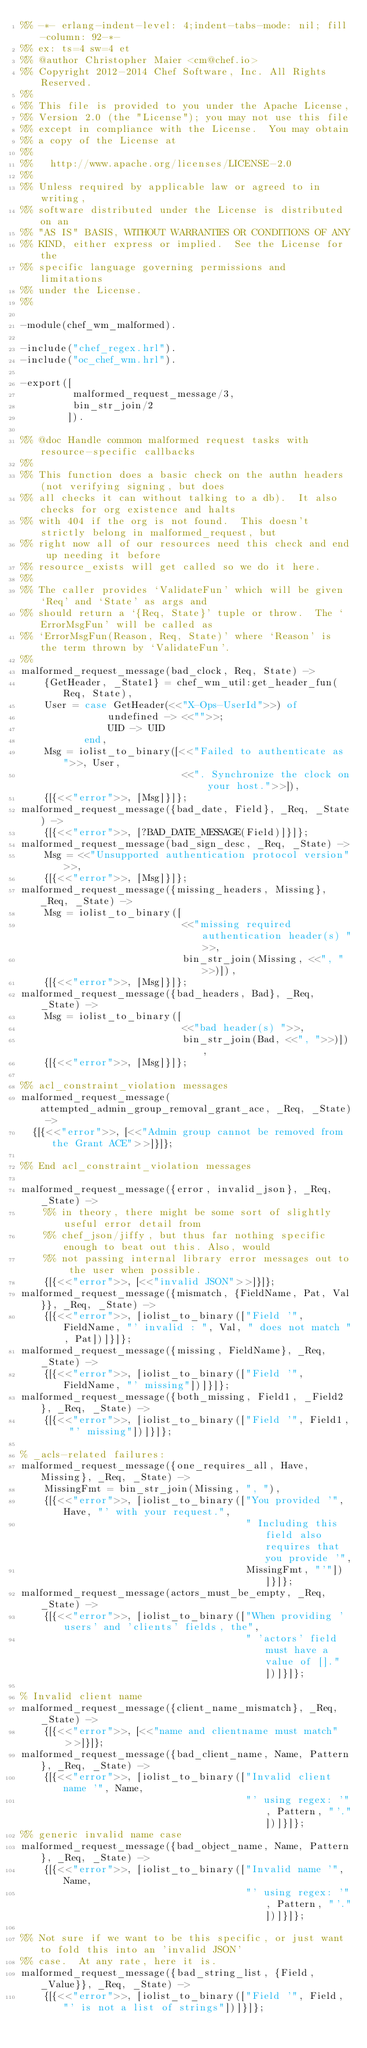Convert code to text. <code><loc_0><loc_0><loc_500><loc_500><_Erlang_>%% -*- erlang-indent-level: 4;indent-tabs-mode: nil; fill-column: 92-*-
%% ex: ts=4 sw=4 et
%% @author Christopher Maier <cm@chef.io>
%% Copyright 2012-2014 Chef Software, Inc. All Rights Reserved.
%%
%% This file is provided to you under the Apache License,
%% Version 2.0 (the "License"); you may not use this file
%% except in compliance with the License.  You may obtain
%% a copy of the License at
%%
%%   http://www.apache.org/licenses/LICENSE-2.0
%%
%% Unless required by applicable law or agreed to in writing,
%% software distributed under the License is distributed on an
%% "AS IS" BASIS, WITHOUT WARRANTIES OR CONDITIONS OF ANY
%% KIND, either express or implied.  See the License for the
%% specific language governing permissions and limitations
%% under the License.
%%

-module(chef_wm_malformed).

-include("chef_regex.hrl").
-include("oc_chef_wm.hrl").

-export([
         malformed_request_message/3,
         bin_str_join/2
        ]).

%% @doc Handle common malformed request tasks with resource-specific callbacks
%%
%% This function does a basic check on the authn headers (not verifying signing, but does
%% all checks it can without talking to a db).  It also checks for org existence and halts
%% with 404 if the org is not found.  This doesn't strictly belong in malformed_request, but
%% right now all of our resources need this check and end up needing it before
%% resource_exists will get called so we do it here.
%%
%% The caller provides `ValidateFun' which will be given `Req' and `State' as args and
%% should return a `{Req, State}' tuple or throw.  The `ErrorMsgFun' will be called as
%% `ErrorMsgFun(Reason, Req, State)' where `Reason' is the term thrown by `ValidateFun'.
%%
malformed_request_message(bad_clock, Req, State) ->
    {GetHeader, _State1} = chef_wm_util:get_header_fun(Req, State),
    User = case GetHeader(<<"X-Ops-UserId">>) of
               undefined -> <<"">>;
               UID -> UID
           end,
    Msg = iolist_to_binary([<<"Failed to authenticate as ">>, User,
                            <<". Synchronize the clock on your host.">>]),
    {[{<<"error">>, [Msg]}]};
malformed_request_message({bad_date, Field}, _Req, _State) ->
    {[{<<"error">>, [?BAD_DATE_MESSAGE(Field)]}]};
malformed_request_message(bad_sign_desc, _Req, _State) ->
    Msg = <<"Unsupported authentication protocol version">>,
    {[{<<"error">>, [Msg]}]};
malformed_request_message({missing_headers, Missing}, _Req, _State) ->
    Msg = iolist_to_binary([
                            <<"missing required authentication header(s) ">>,
                            bin_str_join(Missing, <<", ">>)]),
    {[{<<"error">>, [Msg]}]};
malformed_request_message({bad_headers, Bad}, _Req, _State) ->
    Msg = iolist_to_binary([
                            <<"bad header(s) ">>,
                            bin_str_join(Bad, <<", ">>)]),
    {[{<<"error">>, [Msg]}]};

%% acl_constraint_violation messages
malformed_request_message(attempted_admin_group_removal_grant_ace, _Req, _State) ->
  {[{<<"error">>, [<<"Admin group cannot be removed from the Grant ACE">>]}]};

%% End acl_constraint_violation messages

malformed_request_message({error, invalid_json}, _Req, _State) ->
    %% in theory, there might be some sort of slightly useful error detail from
    %% chef_json/jiffy, but thus far nothing specific enough to beat out this. Also, would
    %% not passing internal library error messages out to the user when possible.
    {[{<<"error">>, [<<"invalid JSON">>]}]};
malformed_request_message({mismatch, {FieldName, Pat, Val}}, _Req, _State) ->
    {[{<<"error">>, [iolist_to_binary(["Field '", FieldName, "' invalid : ", Val, " does not match ", Pat])]}]};
malformed_request_message({missing, FieldName}, _Req, _State) ->
    {[{<<"error">>, [iolist_to_binary(["Field '", FieldName, "' missing"])]}]};
malformed_request_message({both_missing, Field1, _Field2}, _Req, _State) ->
    {[{<<"error">>, [iolist_to_binary(["Field '", Field1, "' missing"])]}]};

% _acls-related failures:
malformed_request_message({one_requires_all, Have, Missing}, _Req, _State) ->
    MissingFmt = bin_str_join(Missing, ", "),
    {[{<<"error">>, [iolist_to_binary(["You provided '", Have, "' with your request.",
                                       " Including this field also requires that you provide '",
                                       MissingFmt, "'"])]}]};
malformed_request_message(actors_must_be_empty, _Req, _State) ->
    {[{<<"error">>, [iolist_to_binary(["When providing 'users' and 'clients' fields, the",
                                       " 'actors' field must have a value of []." ])]}]};

% Invalid client name
malformed_request_message({client_name_mismatch}, _Req, _State) ->
    {[{<<"error">>, [<<"name and clientname must match">>]}]};
malformed_request_message({bad_client_name, Name, Pattern}, _Req, _State) ->
    {[{<<"error">>, [iolist_to_binary(["Invalid client name '", Name,
                                       "' using regex: '", Pattern, "'."])]}]};
%% generic invalid name case
malformed_request_message({bad_object_name, Name, Pattern}, _Req, _State) ->
    {[{<<"error">>, [iolist_to_binary(["Invalid name '", Name,
                                       "' using regex: '", Pattern, "'."])]}]};

%% Not sure if we want to be this specific, or just want to fold this into an 'invalid JSON'
%% case.  At any rate, here it is.
malformed_request_message({bad_string_list, {Field, _Value}}, _Req, _State) ->
    {[{<<"error">>, [iolist_to_binary(["Field '", Field, "' is not a list of strings"])]}]};</code> 